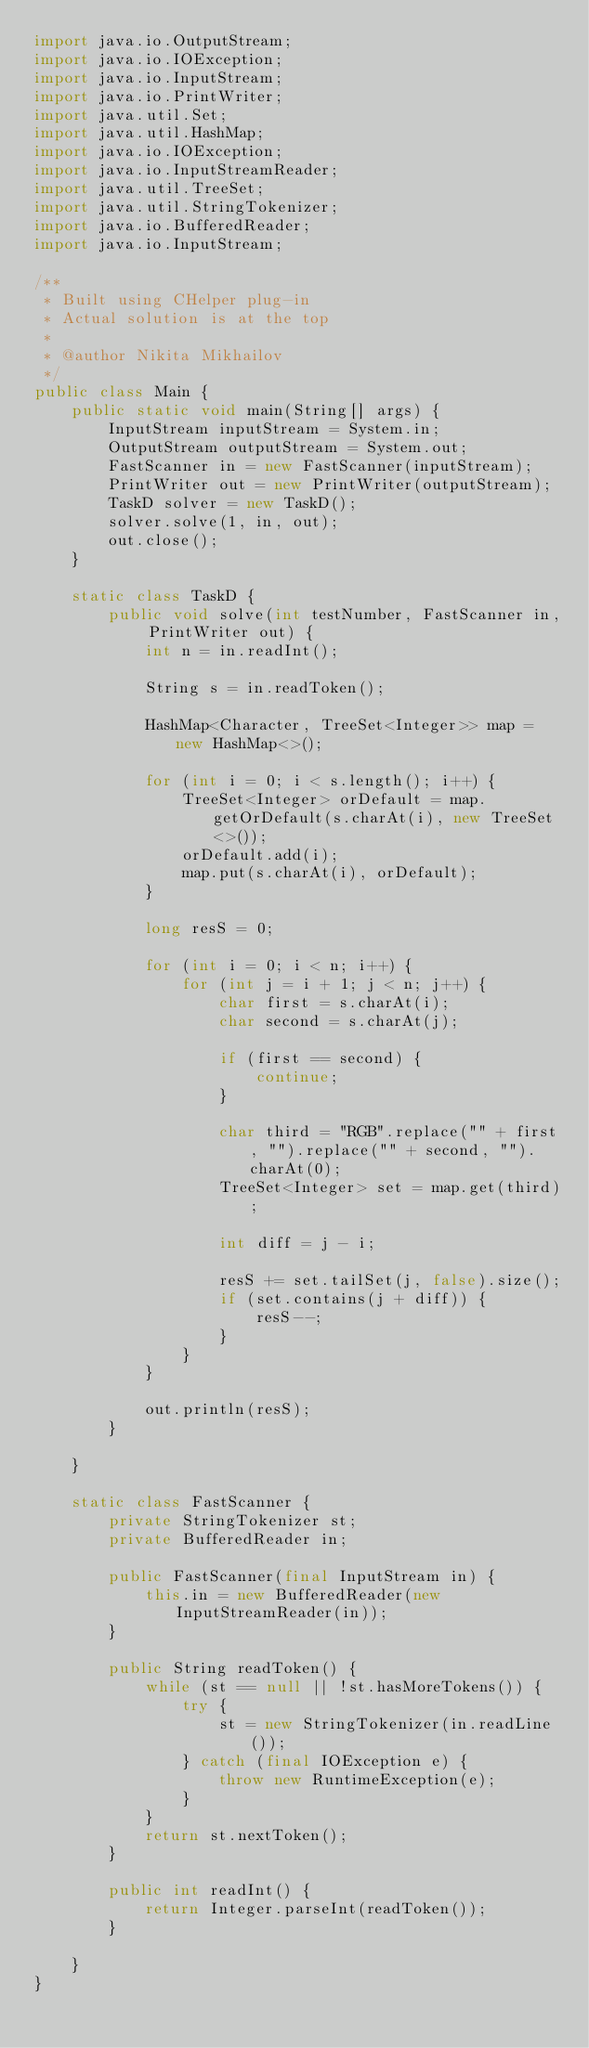Convert code to text. <code><loc_0><loc_0><loc_500><loc_500><_Java_>import java.io.OutputStream;
import java.io.IOException;
import java.io.InputStream;
import java.io.PrintWriter;
import java.util.Set;
import java.util.HashMap;
import java.io.IOException;
import java.io.InputStreamReader;
import java.util.TreeSet;
import java.util.StringTokenizer;
import java.io.BufferedReader;
import java.io.InputStream;

/**
 * Built using CHelper plug-in
 * Actual solution is at the top
 *
 * @author Nikita Mikhailov
 */
public class Main {
    public static void main(String[] args) {
        InputStream inputStream = System.in;
        OutputStream outputStream = System.out;
        FastScanner in = new FastScanner(inputStream);
        PrintWriter out = new PrintWriter(outputStream);
        TaskD solver = new TaskD();
        solver.solve(1, in, out);
        out.close();
    }

    static class TaskD {
        public void solve(int testNumber, FastScanner in, PrintWriter out) {
            int n = in.readInt();

            String s = in.readToken();

            HashMap<Character, TreeSet<Integer>> map = new HashMap<>();

            for (int i = 0; i < s.length(); i++) {
                TreeSet<Integer> orDefault = map.getOrDefault(s.charAt(i), new TreeSet<>());
                orDefault.add(i);
                map.put(s.charAt(i), orDefault);
            }

            long resS = 0;

            for (int i = 0; i < n; i++) {
                for (int j = i + 1; j < n; j++) {
                    char first = s.charAt(i);
                    char second = s.charAt(j);

                    if (first == second) {
                        continue;
                    }

                    char third = "RGB".replace("" + first, "").replace("" + second, "").charAt(0);
                    TreeSet<Integer> set = map.get(third);

                    int diff = j - i;

                    resS += set.tailSet(j, false).size();
                    if (set.contains(j + diff)) {
                        resS--;
                    }
                }
            }

            out.println(resS);
        }

    }

    static class FastScanner {
        private StringTokenizer st;
        private BufferedReader in;

        public FastScanner(final InputStream in) {
            this.in = new BufferedReader(new InputStreamReader(in));
        }

        public String readToken() {
            while (st == null || !st.hasMoreTokens()) {
                try {
                    st = new StringTokenizer(in.readLine());
                } catch (final IOException e) {
                    throw new RuntimeException(e);
                }
            }
            return st.nextToken();
        }

        public int readInt() {
            return Integer.parseInt(readToken());
        }

    }
}

</code> 